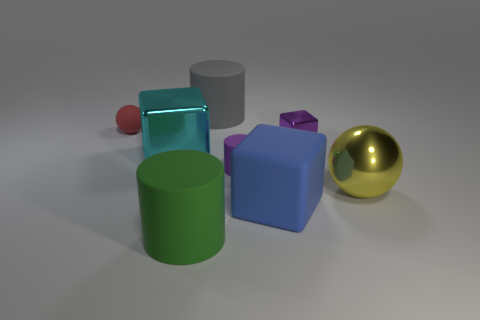What is the size of the block that is made of the same material as the cyan thing?
Give a very brief answer. Small. Is the number of big blue rubber blocks in front of the cyan block greater than the number of green matte cylinders that are on the right side of the green cylinder?
Offer a very short reply. Yes. Are there any small shiny objects that have the same shape as the green matte thing?
Provide a succinct answer. No. There is a shiny thing that is on the left side of the green rubber object; is its size the same as the tiny purple metal block?
Make the answer very short. No. Is there a big yellow ball?
Offer a very short reply. Yes. How many objects are rubber cylinders behind the purple rubber cylinder or shiny objects?
Give a very brief answer. 4. Does the tiny cylinder have the same color as the metal cube right of the large blue matte block?
Make the answer very short. Yes. Is there a yellow sphere of the same size as the red matte object?
Offer a very short reply. No. There is a ball that is behind the metal block that is in front of the small purple block; what is its material?
Offer a terse response. Rubber. What number of tiny cylinders have the same color as the small matte sphere?
Your answer should be compact. 0. 